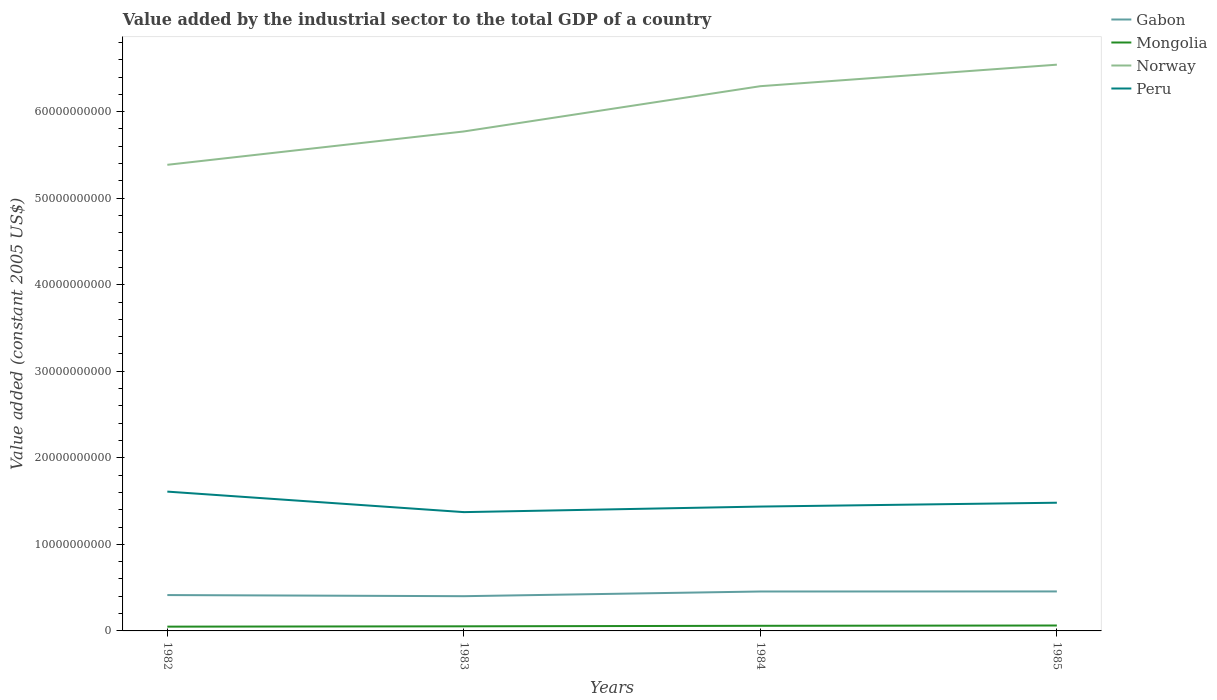How many different coloured lines are there?
Your answer should be very brief. 4. Is the number of lines equal to the number of legend labels?
Provide a short and direct response. Yes. Across all years, what is the maximum value added by the industrial sector in Gabon?
Provide a short and direct response. 4.01e+09. What is the total value added by the industrial sector in Mongolia in the graph?
Your response must be concise. -9.31e+07. What is the difference between the highest and the second highest value added by the industrial sector in Peru?
Provide a succinct answer. 2.37e+09. Is the value added by the industrial sector in Peru strictly greater than the value added by the industrial sector in Gabon over the years?
Give a very brief answer. No. How many years are there in the graph?
Your answer should be compact. 4. Are the values on the major ticks of Y-axis written in scientific E-notation?
Ensure brevity in your answer.  No. Does the graph contain any zero values?
Ensure brevity in your answer.  No. Where does the legend appear in the graph?
Offer a very short reply. Top right. What is the title of the graph?
Your answer should be very brief. Value added by the industrial sector to the total GDP of a country. What is the label or title of the X-axis?
Your answer should be compact. Years. What is the label or title of the Y-axis?
Keep it short and to the point. Value added (constant 2005 US$). What is the Value added (constant 2005 US$) of Gabon in 1982?
Offer a terse response. 4.14e+09. What is the Value added (constant 2005 US$) of Mongolia in 1982?
Your response must be concise. 4.94e+08. What is the Value added (constant 2005 US$) of Norway in 1982?
Your response must be concise. 5.39e+1. What is the Value added (constant 2005 US$) of Peru in 1982?
Provide a succinct answer. 1.61e+1. What is the Value added (constant 2005 US$) in Gabon in 1983?
Keep it short and to the point. 4.01e+09. What is the Value added (constant 2005 US$) of Mongolia in 1983?
Offer a terse response. 5.33e+08. What is the Value added (constant 2005 US$) of Norway in 1983?
Keep it short and to the point. 5.77e+1. What is the Value added (constant 2005 US$) in Peru in 1983?
Offer a very short reply. 1.37e+1. What is the Value added (constant 2005 US$) in Gabon in 1984?
Your answer should be compact. 4.56e+09. What is the Value added (constant 2005 US$) in Mongolia in 1984?
Keep it short and to the point. 5.93e+08. What is the Value added (constant 2005 US$) of Norway in 1984?
Keep it short and to the point. 6.29e+1. What is the Value added (constant 2005 US$) in Peru in 1984?
Your response must be concise. 1.44e+1. What is the Value added (constant 2005 US$) of Gabon in 1985?
Offer a terse response. 4.56e+09. What is the Value added (constant 2005 US$) of Mongolia in 1985?
Your answer should be compact. 6.26e+08. What is the Value added (constant 2005 US$) of Norway in 1985?
Provide a short and direct response. 6.54e+1. What is the Value added (constant 2005 US$) of Peru in 1985?
Offer a terse response. 1.48e+1. Across all years, what is the maximum Value added (constant 2005 US$) in Gabon?
Offer a terse response. 4.56e+09. Across all years, what is the maximum Value added (constant 2005 US$) of Mongolia?
Make the answer very short. 6.26e+08. Across all years, what is the maximum Value added (constant 2005 US$) of Norway?
Your answer should be compact. 6.54e+1. Across all years, what is the maximum Value added (constant 2005 US$) of Peru?
Ensure brevity in your answer.  1.61e+1. Across all years, what is the minimum Value added (constant 2005 US$) of Gabon?
Offer a very short reply. 4.01e+09. Across all years, what is the minimum Value added (constant 2005 US$) in Mongolia?
Give a very brief answer. 4.94e+08. Across all years, what is the minimum Value added (constant 2005 US$) of Norway?
Your answer should be very brief. 5.39e+1. Across all years, what is the minimum Value added (constant 2005 US$) of Peru?
Offer a very short reply. 1.37e+1. What is the total Value added (constant 2005 US$) of Gabon in the graph?
Your answer should be very brief. 1.73e+1. What is the total Value added (constant 2005 US$) in Mongolia in the graph?
Give a very brief answer. 2.25e+09. What is the total Value added (constant 2005 US$) of Norway in the graph?
Keep it short and to the point. 2.40e+11. What is the total Value added (constant 2005 US$) of Peru in the graph?
Your response must be concise. 5.90e+1. What is the difference between the Value added (constant 2005 US$) of Gabon in 1982 and that in 1983?
Your answer should be compact. 1.29e+08. What is the difference between the Value added (constant 2005 US$) in Mongolia in 1982 and that in 1983?
Your response must be concise. -3.88e+07. What is the difference between the Value added (constant 2005 US$) in Norway in 1982 and that in 1983?
Provide a succinct answer. -3.85e+09. What is the difference between the Value added (constant 2005 US$) in Peru in 1982 and that in 1983?
Your response must be concise. 2.37e+09. What is the difference between the Value added (constant 2005 US$) in Gabon in 1982 and that in 1984?
Make the answer very short. -4.13e+08. What is the difference between the Value added (constant 2005 US$) of Mongolia in 1982 and that in 1984?
Your answer should be compact. -9.88e+07. What is the difference between the Value added (constant 2005 US$) of Norway in 1982 and that in 1984?
Give a very brief answer. -9.08e+09. What is the difference between the Value added (constant 2005 US$) in Peru in 1982 and that in 1984?
Make the answer very short. 1.73e+09. What is the difference between the Value added (constant 2005 US$) in Gabon in 1982 and that in 1985?
Ensure brevity in your answer.  -4.19e+08. What is the difference between the Value added (constant 2005 US$) of Mongolia in 1982 and that in 1985?
Offer a very short reply. -1.32e+08. What is the difference between the Value added (constant 2005 US$) in Norway in 1982 and that in 1985?
Your answer should be very brief. -1.16e+1. What is the difference between the Value added (constant 2005 US$) of Peru in 1982 and that in 1985?
Offer a very short reply. 1.28e+09. What is the difference between the Value added (constant 2005 US$) of Gabon in 1983 and that in 1984?
Your response must be concise. -5.42e+08. What is the difference between the Value added (constant 2005 US$) of Mongolia in 1983 and that in 1984?
Offer a very short reply. -6.01e+07. What is the difference between the Value added (constant 2005 US$) of Norway in 1983 and that in 1984?
Give a very brief answer. -5.23e+09. What is the difference between the Value added (constant 2005 US$) in Peru in 1983 and that in 1984?
Offer a very short reply. -6.42e+08. What is the difference between the Value added (constant 2005 US$) of Gabon in 1983 and that in 1985?
Keep it short and to the point. -5.48e+08. What is the difference between the Value added (constant 2005 US$) of Mongolia in 1983 and that in 1985?
Your answer should be compact. -9.31e+07. What is the difference between the Value added (constant 2005 US$) of Norway in 1983 and that in 1985?
Ensure brevity in your answer.  -7.72e+09. What is the difference between the Value added (constant 2005 US$) of Peru in 1983 and that in 1985?
Your answer should be compact. -1.09e+09. What is the difference between the Value added (constant 2005 US$) of Gabon in 1984 and that in 1985?
Your answer should be compact. -5.93e+06. What is the difference between the Value added (constant 2005 US$) of Mongolia in 1984 and that in 1985?
Offer a terse response. -3.31e+07. What is the difference between the Value added (constant 2005 US$) in Norway in 1984 and that in 1985?
Provide a short and direct response. -2.49e+09. What is the difference between the Value added (constant 2005 US$) in Peru in 1984 and that in 1985?
Give a very brief answer. -4.45e+08. What is the difference between the Value added (constant 2005 US$) of Gabon in 1982 and the Value added (constant 2005 US$) of Mongolia in 1983?
Offer a terse response. 3.61e+09. What is the difference between the Value added (constant 2005 US$) in Gabon in 1982 and the Value added (constant 2005 US$) in Norway in 1983?
Provide a short and direct response. -5.36e+1. What is the difference between the Value added (constant 2005 US$) of Gabon in 1982 and the Value added (constant 2005 US$) of Peru in 1983?
Make the answer very short. -9.59e+09. What is the difference between the Value added (constant 2005 US$) in Mongolia in 1982 and the Value added (constant 2005 US$) in Norway in 1983?
Offer a very short reply. -5.72e+1. What is the difference between the Value added (constant 2005 US$) in Mongolia in 1982 and the Value added (constant 2005 US$) in Peru in 1983?
Make the answer very short. -1.32e+1. What is the difference between the Value added (constant 2005 US$) in Norway in 1982 and the Value added (constant 2005 US$) in Peru in 1983?
Give a very brief answer. 4.01e+1. What is the difference between the Value added (constant 2005 US$) in Gabon in 1982 and the Value added (constant 2005 US$) in Mongolia in 1984?
Make the answer very short. 3.55e+09. What is the difference between the Value added (constant 2005 US$) in Gabon in 1982 and the Value added (constant 2005 US$) in Norway in 1984?
Your answer should be very brief. -5.88e+1. What is the difference between the Value added (constant 2005 US$) in Gabon in 1982 and the Value added (constant 2005 US$) in Peru in 1984?
Provide a succinct answer. -1.02e+1. What is the difference between the Value added (constant 2005 US$) in Mongolia in 1982 and the Value added (constant 2005 US$) in Norway in 1984?
Make the answer very short. -6.25e+1. What is the difference between the Value added (constant 2005 US$) of Mongolia in 1982 and the Value added (constant 2005 US$) of Peru in 1984?
Give a very brief answer. -1.39e+1. What is the difference between the Value added (constant 2005 US$) in Norway in 1982 and the Value added (constant 2005 US$) in Peru in 1984?
Offer a very short reply. 3.95e+1. What is the difference between the Value added (constant 2005 US$) in Gabon in 1982 and the Value added (constant 2005 US$) in Mongolia in 1985?
Your answer should be compact. 3.52e+09. What is the difference between the Value added (constant 2005 US$) in Gabon in 1982 and the Value added (constant 2005 US$) in Norway in 1985?
Offer a very short reply. -6.13e+1. What is the difference between the Value added (constant 2005 US$) in Gabon in 1982 and the Value added (constant 2005 US$) in Peru in 1985?
Provide a succinct answer. -1.07e+1. What is the difference between the Value added (constant 2005 US$) of Mongolia in 1982 and the Value added (constant 2005 US$) of Norway in 1985?
Provide a short and direct response. -6.49e+1. What is the difference between the Value added (constant 2005 US$) in Mongolia in 1982 and the Value added (constant 2005 US$) in Peru in 1985?
Make the answer very short. -1.43e+1. What is the difference between the Value added (constant 2005 US$) of Norway in 1982 and the Value added (constant 2005 US$) of Peru in 1985?
Keep it short and to the point. 3.90e+1. What is the difference between the Value added (constant 2005 US$) in Gabon in 1983 and the Value added (constant 2005 US$) in Mongolia in 1984?
Make the answer very short. 3.42e+09. What is the difference between the Value added (constant 2005 US$) in Gabon in 1983 and the Value added (constant 2005 US$) in Norway in 1984?
Keep it short and to the point. -5.89e+1. What is the difference between the Value added (constant 2005 US$) in Gabon in 1983 and the Value added (constant 2005 US$) in Peru in 1984?
Your response must be concise. -1.04e+1. What is the difference between the Value added (constant 2005 US$) of Mongolia in 1983 and the Value added (constant 2005 US$) of Norway in 1984?
Make the answer very short. -6.24e+1. What is the difference between the Value added (constant 2005 US$) of Mongolia in 1983 and the Value added (constant 2005 US$) of Peru in 1984?
Make the answer very short. -1.38e+1. What is the difference between the Value added (constant 2005 US$) in Norway in 1983 and the Value added (constant 2005 US$) in Peru in 1984?
Provide a succinct answer. 4.33e+1. What is the difference between the Value added (constant 2005 US$) in Gabon in 1983 and the Value added (constant 2005 US$) in Mongolia in 1985?
Provide a succinct answer. 3.39e+09. What is the difference between the Value added (constant 2005 US$) in Gabon in 1983 and the Value added (constant 2005 US$) in Norway in 1985?
Provide a succinct answer. -6.14e+1. What is the difference between the Value added (constant 2005 US$) of Gabon in 1983 and the Value added (constant 2005 US$) of Peru in 1985?
Offer a very short reply. -1.08e+1. What is the difference between the Value added (constant 2005 US$) of Mongolia in 1983 and the Value added (constant 2005 US$) of Norway in 1985?
Your response must be concise. -6.49e+1. What is the difference between the Value added (constant 2005 US$) of Mongolia in 1983 and the Value added (constant 2005 US$) of Peru in 1985?
Your response must be concise. -1.43e+1. What is the difference between the Value added (constant 2005 US$) of Norway in 1983 and the Value added (constant 2005 US$) of Peru in 1985?
Offer a very short reply. 4.29e+1. What is the difference between the Value added (constant 2005 US$) in Gabon in 1984 and the Value added (constant 2005 US$) in Mongolia in 1985?
Provide a succinct answer. 3.93e+09. What is the difference between the Value added (constant 2005 US$) of Gabon in 1984 and the Value added (constant 2005 US$) of Norway in 1985?
Provide a short and direct response. -6.09e+1. What is the difference between the Value added (constant 2005 US$) in Gabon in 1984 and the Value added (constant 2005 US$) in Peru in 1985?
Your answer should be very brief. -1.03e+1. What is the difference between the Value added (constant 2005 US$) of Mongolia in 1984 and the Value added (constant 2005 US$) of Norway in 1985?
Your answer should be compact. -6.48e+1. What is the difference between the Value added (constant 2005 US$) in Mongolia in 1984 and the Value added (constant 2005 US$) in Peru in 1985?
Ensure brevity in your answer.  -1.42e+1. What is the difference between the Value added (constant 2005 US$) of Norway in 1984 and the Value added (constant 2005 US$) of Peru in 1985?
Make the answer very short. 4.81e+1. What is the average Value added (constant 2005 US$) in Gabon per year?
Give a very brief answer. 4.32e+09. What is the average Value added (constant 2005 US$) of Mongolia per year?
Provide a succinct answer. 5.61e+08. What is the average Value added (constant 2005 US$) in Norway per year?
Your answer should be very brief. 6.00e+1. What is the average Value added (constant 2005 US$) in Peru per year?
Provide a short and direct response. 1.48e+1. In the year 1982, what is the difference between the Value added (constant 2005 US$) in Gabon and Value added (constant 2005 US$) in Mongolia?
Keep it short and to the point. 3.65e+09. In the year 1982, what is the difference between the Value added (constant 2005 US$) in Gabon and Value added (constant 2005 US$) in Norway?
Offer a terse response. -4.97e+1. In the year 1982, what is the difference between the Value added (constant 2005 US$) in Gabon and Value added (constant 2005 US$) in Peru?
Provide a succinct answer. -1.20e+1. In the year 1982, what is the difference between the Value added (constant 2005 US$) in Mongolia and Value added (constant 2005 US$) in Norway?
Your answer should be very brief. -5.34e+1. In the year 1982, what is the difference between the Value added (constant 2005 US$) of Mongolia and Value added (constant 2005 US$) of Peru?
Offer a very short reply. -1.56e+1. In the year 1982, what is the difference between the Value added (constant 2005 US$) of Norway and Value added (constant 2005 US$) of Peru?
Your answer should be very brief. 3.78e+1. In the year 1983, what is the difference between the Value added (constant 2005 US$) in Gabon and Value added (constant 2005 US$) in Mongolia?
Offer a terse response. 3.48e+09. In the year 1983, what is the difference between the Value added (constant 2005 US$) of Gabon and Value added (constant 2005 US$) of Norway?
Offer a terse response. -5.37e+1. In the year 1983, what is the difference between the Value added (constant 2005 US$) in Gabon and Value added (constant 2005 US$) in Peru?
Provide a short and direct response. -9.71e+09. In the year 1983, what is the difference between the Value added (constant 2005 US$) of Mongolia and Value added (constant 2005 US$) of Norway?
Make the answer very short. -5.72e+1. In the year 1983, what is the difference between the Value added (constant 2005 US$) of Mongolia and Value added (constant 2005 US$) of Peru?
Make the answer very short. -1.32e+1. In the year 1983, what is the difference between the Value added (constant 2005 US$) of Norway and Value added (constant 2005 US$) of Peru?
Your answer should be compact. 4.40e+1. In the year 1984, what is the difference between the Value added (constant 2005 US$) of Gabon and Value added (constant 2005 US$) of Mongolia?
Offer a terse response. 3.96e+09. In the year 1984, what is the difference between the Value added (constant 2005 US$) in Gabon and Value added (constant 2005 US$) in Norway?
Your response must be concise. -5.84e+1. In the year 1984, what is the difference between the Value added (constant 2005 US$) in Gabon and Value added (constant 2005 US$) in Peru?
Keep it short and to the point. -9.81e+09. In the year 1984, what is the difference between the Value added (constant 2005 US$) of Mongolia and Value added (constant 2005 US$) of Norway?
Provide a short and direct response. -6.24e+1. In the year 1984, what is the difference between the Value added (constant 2005 US$) of Mongolia and Value added (constant 2005 US$) of Peru?
Ensure brevity in your answer.  -1.38e+1. In the year 1984, what is the difference between the Value added (constant 2005 US$) in Norway and Value added (constant 2005 US$) in Peru?
Offer a very short reply. 4.86e+1. In the year 1985, what is the difference between the Value added (constant 2005 US$) in Gabon and Value added (constant 2005 US$) in Mongolia?
Ensure brevity in your answer.  3.94e+09. In the year 1985, what is the difference between the Value added (constant 2005 US$) in Gabon and Value added (constant 2005 US$) in Norway?
Provide a succinct answer. -6.09e+1. In the year 1985, what is the difference between the Value added (constant 2005 US$) of Gabon and Value added (constant 2005 US$) of Peru?
Make the answer very short. -1.03e+1. In the year 1985, what is the difference between the Value added (constant 2005 US$) in Mongolia and Value added (constant 2005 US$) in Norway?
Keep it short and to the point. -6.48e+1. In the year 1985, what is the difference between the Value added (constant 2005 US$) of Mongolia and Value added (constant 2005 US$) of Peru?
Give a very brief answer. -1.42e+1. In the year 1985, what is the difference between the Value added (constant 2005 US$) of Norway and Value added (constant 2005 US$) of Peru?
Provide a succinct answer. 5.06e+1. What is the ratio of the Value added (constant 2005 US$) of Gabon in 1982 to that in 1983?
Your answer should be very brief. 1.03. What is the ratio of the Value added (constant 2005 US$) of Mongolia in 1982 to that in 1983?
Keep it short and to the point. 0.93. What is the ratio of the Value added (constant 2005 US$) in Norway in 1982 to that in 1983?
Offer a terse response. 0.93. What is the ratio of the Value added (constant 2005 US$) in Peru in 1982 to that in 1983?
Offer a very short reply. 1.17. What is the ratio of the Value added (constant 2005 US$) of Gabon in 1982 to that in 1984?
Your answer should be compact. 0.91. What is the ratio of the Value added (constant 2005 US$) of Mongolia in 1982 to that in 1984?
Give a very brief answer. 0.83. What is the ratio of the Value added (constant 2005 US$) of Norway in 1982 to that in 1984?
Provide a short and direct response. 0.86. What is the ratio of the Value added (constant 2005 US$) in Peru in 1982 to that in 1984?
Offer a terse response. 1.12. What is the ratio of the Value added (constant 2005 US$) of Gabon in 1982 to that in 1985?
Make the answer very short. 0.91. What is the ratio of the Value added (constant 2005 US$) of Mongolia in 1982 to that in 1985?
Keep it short and to the point. 0.79. What is the ratio of the Value added (constant 2005 US$) of Norway in 1982 to that in 1985?
Keep it short and to the point. 0.82. What is the ratio of the Value added (constant 2005 US$) of Peru in 1982 to that in 1985?
Your answer should be very brief. 1.09. What is the ratio of the Value added (constant 2005 US$) of Gabon in 1983 to that in 1984?
Make the answer very short. 0.88. What is the ratio of the Value added (constant 2005 US$) of Mongolia in 1983 to that in 1984?
Offer a terse response. 0.9. What is the ratio of the Value added (constant 2005 US$) of Norway in 1983 to that in 1984?
Provide a short and direct response. 0.92. What is the ratio of the Value added (constant 2005 US$) of Peru in 1983 to that in 1984?
Ensure brevity in your answer.  0.96. What is the ratio of the Value added (constant 2005 US$) in Gabon in 1983 to that in 1985?
Your answer should be compact. 0.88. What is the ratio of the Value added (constant 2005 US$) in Mongolia in 1983 to that in 1985?
Make the answer very short. 0.85. What is the ratio of the Value added (constant 2005 US$) in Norway in 1983 to that in 1985?
Offer a terse response. 0.88. What is the ratio of the Value added (constant 2005 US$) in Peru in 1983 to that in 1985?
Provide a succinct answer. 0.93. What is the ratio of the Value added (constant 2005 US$) in Mongolia in 1984 to that in 1985?
Your response must be concise. 0.95. What is the ratio of the Value added (constant 2005 US$) of Norway in 1984 to that in 1985?
Give a very brief answer. 0.96. What is the difference between the highest and the second highest Value added (constant 2005 US$) of Gabon?
Provide a succinct answer. 5.93e+06. What is the difference between the highest and the second highest Value added (constant 2005 US$) of Mongolia?
Make the answer very short. 3.31e+07. What is the difference between the highest and the second highest Value added (constant 2005 US$) in Norway?
Your answer should be very brief. 2.49e+09. What is the difference between the highest and the second highest Value added (constant 2005 US$) in Peru?
Your response must be concise. 1.28e+09. What is the difference between the highest and the lowest Value added (constant 2005 US$) of Gabon?
Provide a short and direct response. 5.48e+08. What is the difference between the highest and the lowest Value added (constant 2005 US$) in Mongolia?
Your answer should be compact. 1.32e+08. What is the difference between the highest and the lowest Value added (constant 2005 US$) in Norway?
Give a very brief answer. 1.16e+1. What is the difference between the highest and the lowest Value added (constant 2005 US$) of Peru?
Your response must be concise. 2.37e+09. 